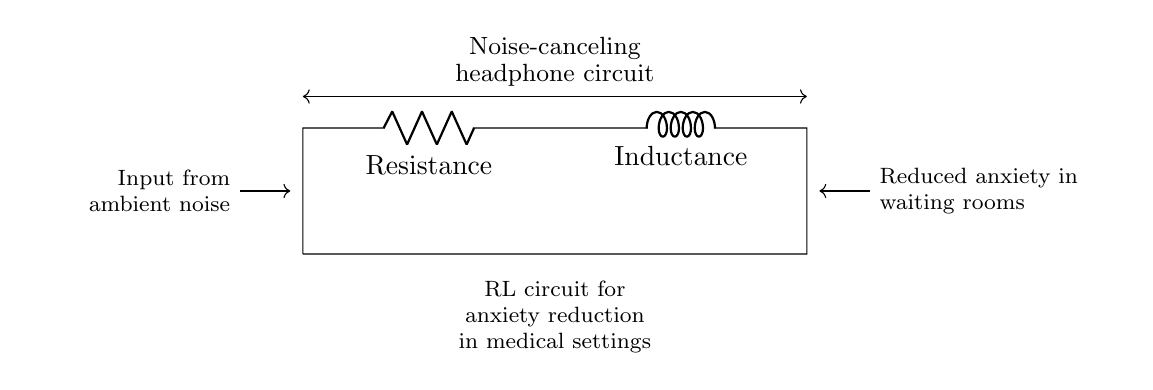What components are present in this circuit? The circuit contains a resistor and an inductor. These are explicitly labeled in the diagram. The resistor is identified by "R" and the inductor by "L".
Answer: Resistor and Inductor What is the main purpose of this RL circuit? The diagram indicates that the circuit is designed for anxiety reduction in medical settings, particularly through noise-canceling headphones. This purpose is stated explicitly beneath the circuit.
Answer: Anxiety reduction How do noise-canceling headphones work with this circuit? The circuit takes input from ambient noise, which is processed by the resistor and inductor to reduce sound, thereby calming anxiety. This explanation can be derived from the flow of information presented in the diagram.
Answer: By reducing ambient noise What happens to the ambient noise input? The ambient noise input is processed through the circuit, resulting in reduced noise output meant for calming the user. The diagram shows the pathway for this noise from input to its effect.
Answer: Reduced noise output What type of circuit is shown in the diagram? The presented circuit is identified as an RL circuit, characterized by the combination of a resistor and an inductor connected in series. This classification is mentioned in the diagram as well.
Answer: RL circuit 